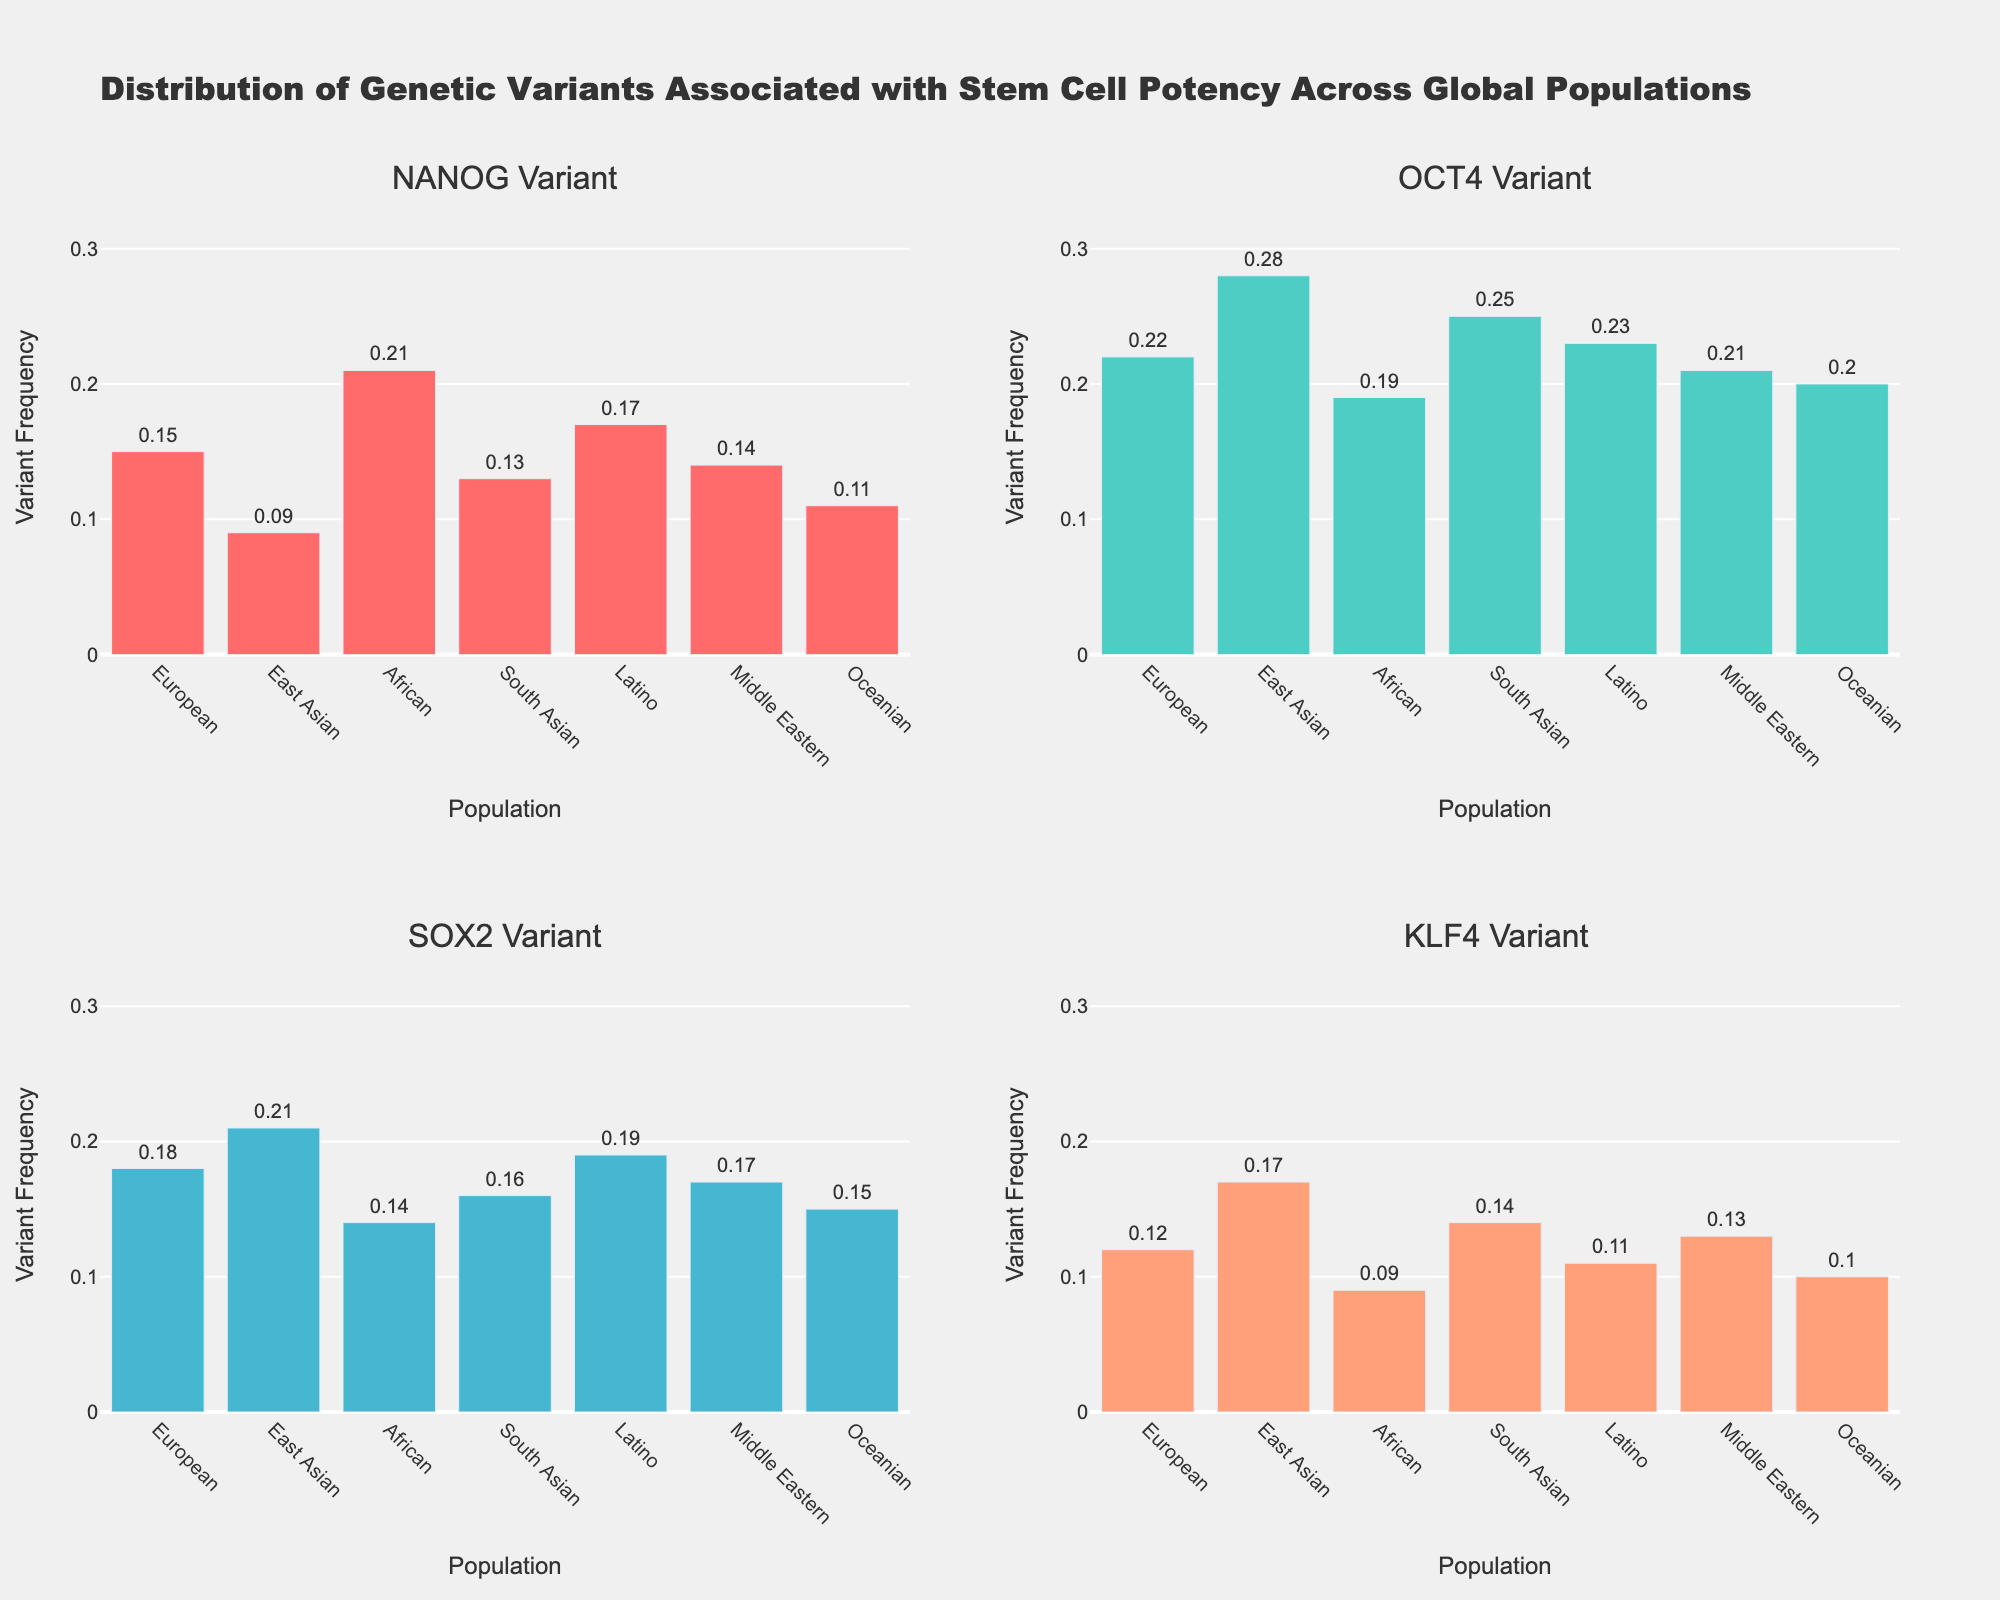What's the title of the figure? The title is clearly displayed at the top of the figure. It reads "Distribution of Genetic Variants Associated with Stem Cell Potency Across Global Populations".
Answer: Distribution of Genetic Variants Associated with Stem Cell Potency Across Global Populations Which population has the highest frequency of the NANOG variant? The bar representing the NANOG variant frequency for each population shows that the African population has the highest value.
Answer: African What is the average frequency of the OCT4 variant across all populations? Sum the frequencies for the OCT4 variant across all populations (0.22 + 0.28 + 0.19 + 0.25 + 0.23 + 0.21 + 0.20) and divide by the number of populations (7). The calculation is (1.58) / 7 = 0.226 approximated to three decimal places.
Answer: 0.23 Which variant shows the greatest range in frequency across populations? The range is calculated by subtracting the smallest frequency from the largest frequency in each variant. 
NANOG: 0.21 - 0.09 = 0.12,
OCT4: 0.28 - 0.19 = 0.09,
SOX2: 0.21 - 0.14 = 0.07,
KLF4: 0.17 - 0.09 = 0.08.
The NANOG variant has the greatest range.
Answer: NANOG Comparing the KLF4 variant, which two populations have an equal frequency? By observing the heights and values of the bars for the KLF4 variant, both the South Asian and Middle Eastern populations have the same frequency of 0.14.
Answer: South Asian and Middle Eastern Which population has the second highest frequency for the SOX2 variant? By looking at the bars for the SOX2 variant, the second highest bar belongs to the East Asian population after the Latino population.
Answer: East Asian What's the difference in frequency between the European and the Oceanian population for the NANOG variant? Subtract the frequency of the NANOG variant for the Oceanian population from the frequency for the European population (0.15 - 0.11). The calculation: 0.15 - 0.11 = 0.04.
Answer: 0.04 Are there any populations with frequencies above 0.25 for any variant? If so, which ones? By scanning each subplot, the East Asian population has a frequency of 0.28 for the OCT4 variant and the South Asian population has a frequency of 0.25 for the OCT4 variant.
Answer: East Asian and South Asian Compare the variant frequencies for the African and Latino populations. Which variants have a higher frequency in the African population? Observe the bars for both populations across all variants. The NANOG variant (0.21 > 0.17) has a higher frequency for the African population, while the others are lower or equal.
Answer: NANOG What is the combined frequency of the NANOG and OCT4 variants for the Middle Eastern population? Add the frequencies of the NANOG variant (0.14) and the OCT4 variant (0.21) for the Middle Eastern population: 0.14 + 0.21 = 0.35.
Answer: 0.35 